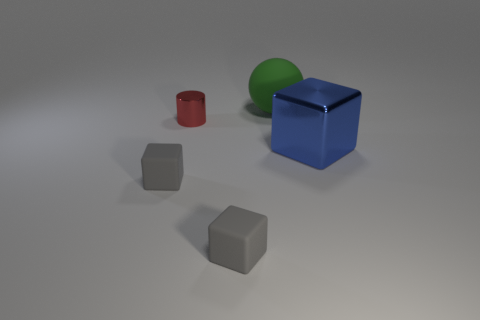Add 3 rubber spheres. How many objects exist? 8 Subtract all balls. How many objects are left? 4 Subtract 0 brown blocks. How many objects are left? 5 Subtract all cylinders. Subtract all big spheres. How many objects are left? 3 Add 4 big balls. How many big balls are left? 5 Add 3 large blue cubes. How many large blue cubes exist? 4 